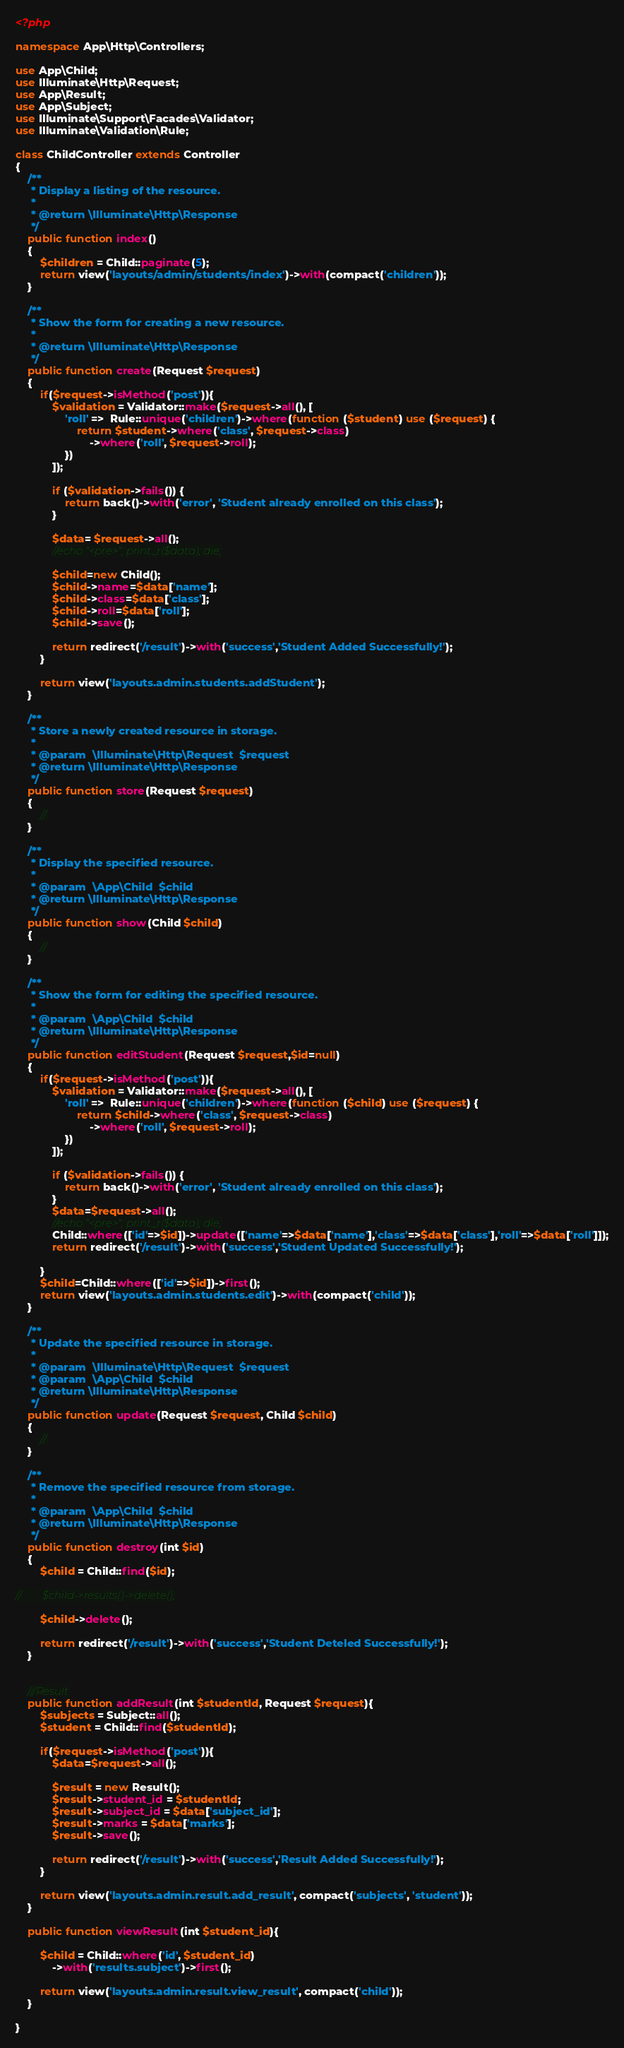Convert code to text. <code><loc_0><loc_0><loc_500><loc_500><_PHP_><?php

namespace App\Http\Controllers;

use App\Child;
use Illuminate\Http\Request;
use App\Result;
use App\Subject;
use Illuminate\Support\Facades\Validator;
use Illuminate\Validation\Rule;

class ChildController extends Controller
{
    /**
     * Display a listing of the resource.
     *
     * @return \Illuminate\Http\Response
     */
    public function index()
    {
        $children = Child::paginate(5);
        return view('layouts/admin/students/index')->with(compact('children'));
    }

    /**
     * Show the form for creating a new resource.
     *
     * @return \Illuminate\Http\Response
     */
    public function create(Request $request)
    {
        if($request->isMethod('post')){
            $validation = Validator::make($request->all(), [
                'roll' =>  Rule::unique('children')->where(function ($student) use ($request) {
                    return $student->where('class', $request->class)
                        ->where('roll', $request->roll);
                })
            ]);

            if ($validation->fails()) {
                return back()->with('error', 'Student already enrolled on this class');
            }

            $data= $request->all();
            //echo "<pre>"; print_r($data); die;

            $child=new Child();
            $child->name=$data['name'];
            $child->class=$data['class'];
            $child->roll=$data['roll'];
            $child->save();

            return redirect('/result')->with('success','Student Added Successfully!');
        }

        return view('layouts.admin.students.addStudent');
    }

    /**
     * Store a newly created resource in storage.
     *
     * @param  \Illuminate\Http\Request  $request
     * @return \Illuminate\Http\Response
     */
    public function store(Request $request)
    {
        //
    }

    /**
     * Display the specified resource.
     *
     * @param  \App\Child  $child
     * @return \Illuminate\Http\Response
     */
    public function show(Child $child)
    {
        //
    }

    /**
     * Show the form for editing the specified resource.
     *
     * @param  \App\Child  $child
     * @return \Illuminate\Http\Response
     */
    public function editStudent(Request $request,$id=null)
    {
        if($request->isMethod('post')){
            $validation = Validator::make($request->all(), [
                'roll' =>  Rule::unique('children')->where(function ($child) use ($request) {
                    return $child->where('class', $request->class)
                        ->where('roll', $request->roll);
                })
            ]);

            if ($validation->fails()) {
                return back()->with('error', 'Student already enrolled on this class');
            }
            $data=$request->all();
            //echo "<pre>"; print_r($data); die;
            Child::where(['id'=>$id])->update(['name'=>$data['name'],'class'=>$data['class'],'roll'=>$data['roll']]);
            return redirect('/result')->with('success','Student Updated Successfully!');

        }
        $child=Child::where(['id'=>$id])->first();
        return view('layouts.admin.students.edit')->with(compact('child'));
    }

    /**
     * Update the specified resource in storage.
     *
     * @param  \Illuminate\Http\Request  $request
     * @param  \App\Child  $child
     * @return \Illuminate\Http\Response
     */
    public function update(Request $request, Child $child)
    {
        //
    }

    /**
     * Remove the specified resource from storage.
     *
     * @param  \App\Child  $child
     * @return \Illuminate\Http\Response
     */
    public function destroy(int $id)
    {
        $child = Child::find($id);

//        $child->results()->delete();

        $child->delete();

        return redirect('/result')->with('success','Student Deteled Successfully!');
    }


    ///Result
    public function addResult(int $studentId, Request $request){
        $subjects = Subject::all();
        $student = Child::find($studentId);

        if($request->isMethod('post')){
            $data=$request->all();

            $result = new Result();
            $result->student_id = $studentId;
            $result->subject_id = $data['subject_id'];
            $result->marks = $data['marks'];
            $result->save();

            return redirect('/result')->with('success','Result Added Successfully!');
        }

        return view('layouts.admin.result.add_result', compact('subjects', 'student'));
    }

    public function viewResult(int $student_id){

        $child = Child::where('id', $student_id)
            ->with('results.subject')->first();

        return view('layouts.admin.result.view_result', compact('child'));
    }

}
</code> 